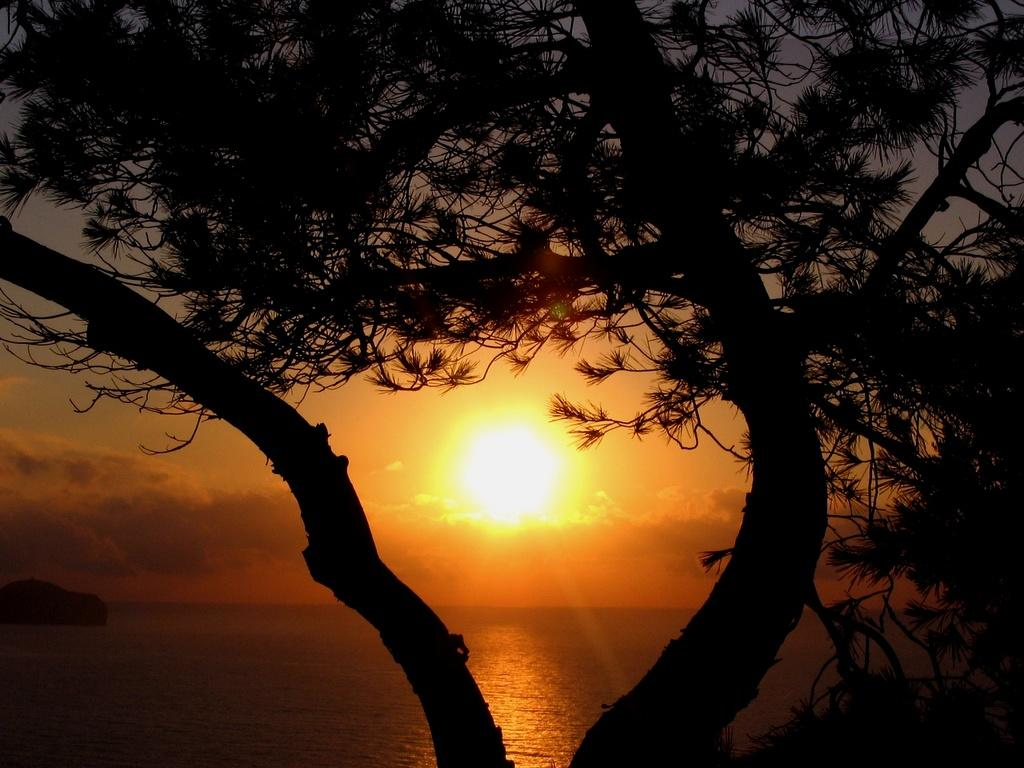What is located in the foreground of the picture? There is a tree in the foreground of the picture. What can be seen in the center of the image? There is a water body in the center of the image. What is visible in the background of the image? There are clouds and the sun visible in the sky in the background of the image. Who is the representative standing next to the tree in the image? There is no representative present in the image; it features a tree, a water body, clouds, and the sun. What type of cake is being served near the water body in the image? There is no cake present in the image; it features a tree, a water body, clouds, and the sun. 